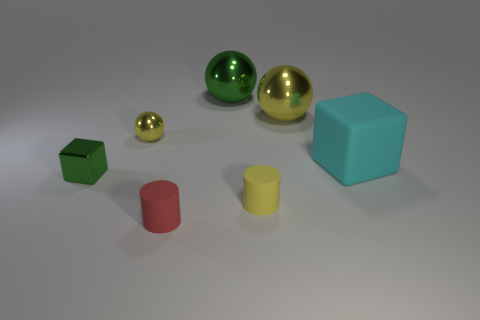There is a green thing on the right side of the small shiny thing that is left of the yellow sphere in front of the large yellow shiny sphere; what is its size? The green object you are referring to appears to be a medium-sized, green cube. It's situated to the right of a small gold sphere and to the left of a larger yellow, shiny sphere. 